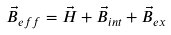<formula> <loc_0><loc_0><loc_500><loc_500>\vec { B } _ { e f f } = \vec { H } + \vec { B } _ { i n t } + \vec { B } _ { e x }</formula> 